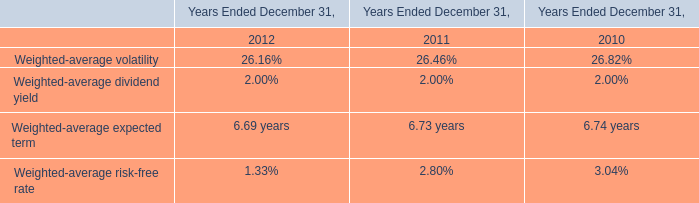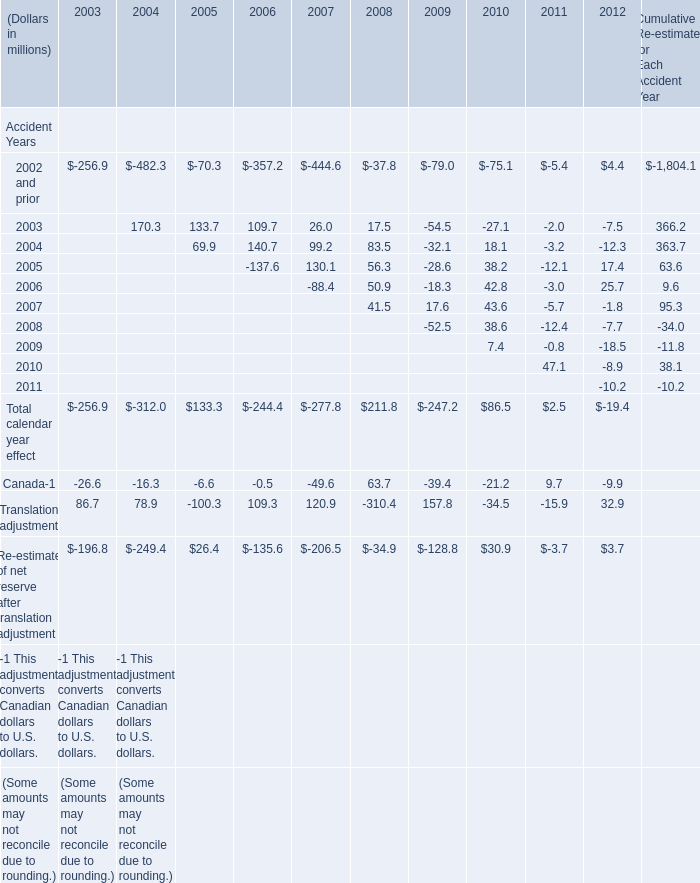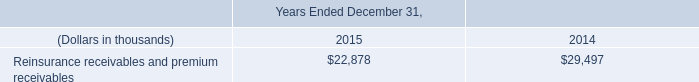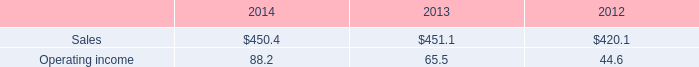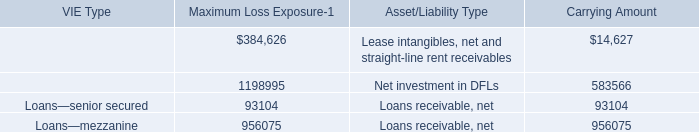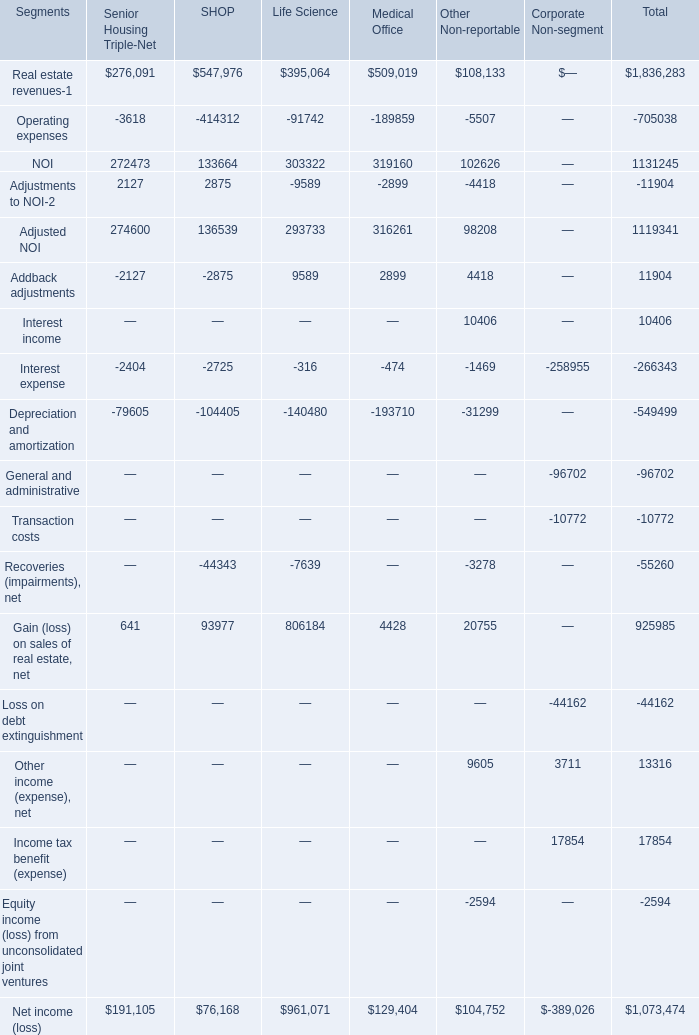What is the sum of Accident Years in 2005? (in million) 
Computations: ((-70.3 + 133.7) + 69.9)
Answer: 133.3. 